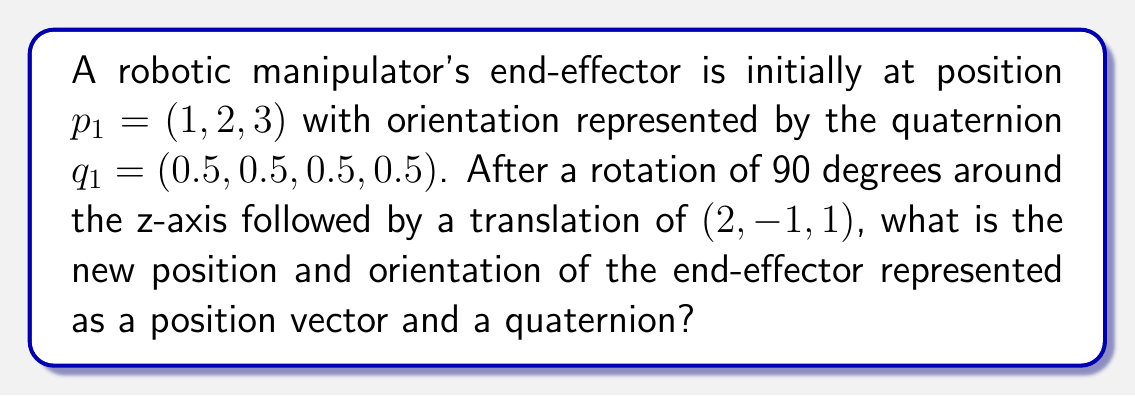Can you answer this question? 1. Rotation:
   The quaternion representing a 90-degree rotation around the z-axis is:
   $$q_r = (\cos(\frac{\pi}{4}), 0, 0, \sin(\frac{\pi}{4})) = (\frac{\sqrt{2}}{2}, 0, 0, \frac{\sqrt{2}}{2})$$

2. New orientation:
   To compute the new orientation, we multiply the initial quaternion by the rotation quaternion:
   $$q_2 = q_r * q_1 = (\frac{\sqrt{2}}{2}, 0, 0, \frac{\sqrt{2}}{2}) * (0.5, 0.5, 0.5, 0.5)$$
   
   Using quaternion multiplication:
   $$q_2 = (0.5, 0.5, -0.5, 0.5)$$

3. Rotation matrix:
   Convert the rotation quaternion to a rotation matrix:
   $$R = \begin{bmatrix}
   0 & -1 & 0 \\
   1 & 0 & 0 \\
   0 & 0 & 1
   \end{bmatrix}$$

4. New position:
   Apply the rotation and translation to the initial position:
   $$p_2 = R * p_1 + t$$
   Where $t = (2, -1, 1)$ is the translation vector.

   $$p_2 = \begin{bmatrix}
   0 & -1 & 0 \\
   1 & 0 & 0 \\
   0 & 0 & 1
   \end{bmatrix} \begin{bmatrix} 1 \\ 2 \\ 3 \end{bmatrix} + \begin{bmatrix} 2 \\ -1 \\ 1 \end{bmatrix}$$

   $$p_2 = \begin{bmatrix} -2 \\ 1 \\ 3 \end{bmatrix} + \begin{bmatrix} 2 \\ -1 \\ 1 \end{bmatrix} = \begin{bmatrix} 0 \\ 0 \\ 4 \end{bmatrix}$$

Therefore, the new position is $(0, 0, 4)$ and the new orientation quaternion is $(0.5, 0.5, -0.5, 0.5)$.
Answer: Position: $(0, 0, 4)$, Quaternion: $(0.5, 0.5, -0.5, 0.5)$ 